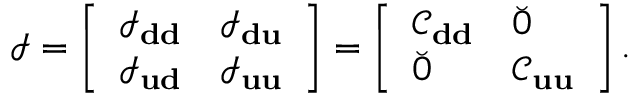<formula> <loc_0><loc_0><loc_500><loc_500>\mathcal { I } = \left [ \begin{array} { l l } { \mathcal { I } _ { d d } } & { \mathcal { I } _ { d u } } \\ { \mathcal { I } _ { u d } } & { \mathcal { I } _ { u u } } \end{array} \right ] = \left [ \begin{array} { l l } { \mathcal { C } _ { d d } } & { \breve { 0 } } \\ { \breve { 0 } } & { \mathcal { C } _ { u u } } \end{array} \right ] .</formula> 